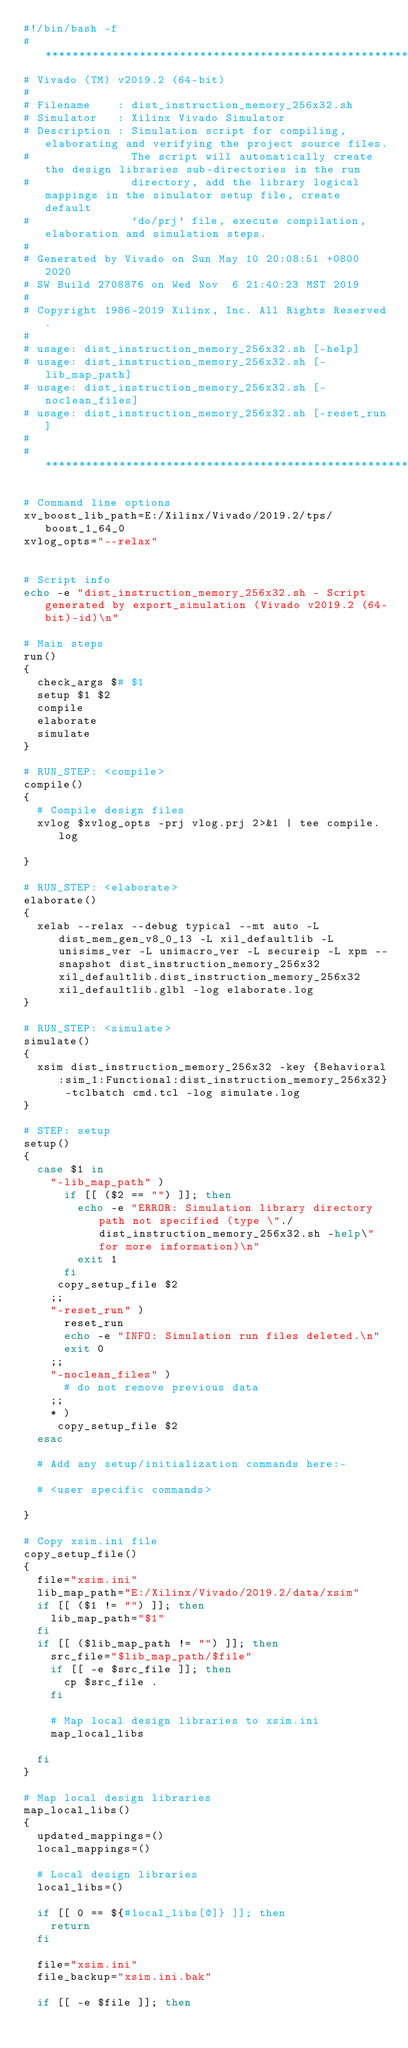<code> <loc_0><loc_0><loc_500><loc_500><_Bash_>#!/bin/bash -f
#*********************************************************************************************************
# Vivado (TM) v2019.2 (64-bit)
#
# Filename    : dist_instruction_memory_256x32.sh
# Simulator   : Xilinx Vivado Simulator
# Description : Simulation script for compiling, elaborating and verifying the project source files.
#               The script will automatically create the design libraries sub-directories in the run
#               directory, add the library logical mappings in the simulator setup file, create default
#               'do/prj' file, execute compilation, elaboration and simulation steps.
#
# Generated by Vivado on Sun May 10 20:08:51 +0800 2020
# SW Build 2708876 on Wed Nov  6 21:40:23 MST 2019
#
# Copyright 1986-2019 Xilinx, Inc. All Rights Reserved. 
#
# usage: dist_instruction_memory_256x32.sh [-help]
# usage: dist_instruction_memory_256x32.sh [-lib_map_path]
# usage: dist_instruction_memory_256x32.sh [-noclean_files]
# usage: dist_instruction_memory_256x32.sh [-reset_run]
#
#*********************************************************************************************************

# Command line options
xv_boost_lib_path=E:/Xilinx/Vivado/2019.2/tps/boost_1_64_0
xvlog_opts="--relax"


# Script info
echo -e "dist_instruction_memory_256x32.sh - Script generated by export_simulation (Vivado v2019.2 (64-bit)-id)\n"

# Main steps
run()
{
  check_args $# $1
  setup $1 $2
  compile
  elaborate
  simulate
}

# RUN_STEP: <compile>
compile()
{
  # Compile design files
  xvlog $xvlog_opts -prj vlog.prj 2>&1 | tee compile.log

}

# RUN_STEP: <elaborate>
elaborate()
{
  xelab --relax --debug typical --mt auto -L dist_mem_gen_v8_0_13 -L xil_defaultlib -L unisims_ver -L unimacro_ver -L secureip -L xpm --snapshot dist_instruction_memory_256x32 xil_defaultlib.dist_instruction_memory_256x32 xil_defaultlib.glbl -log elaborate.log
}

# RUN_STEP: <simulate>
simulate()
{
  xsim dist_instruction_memory_256x32 -key {Behavioral:sim_1:Functional:dist_instruction_memory_256x32} -tclbatch cmd.tcl -log simulate.log
}

# STEP: setup
setup()
{
  case $1 in
    "-lib_map_path" )
      if [[ ($2 == "") ]]; then
        echo -e "ERROR: Simulation library directory path not specified (type \"./dist_instruction_memory_256x32.sh -help\" for more information)\n"
        exit 1
      fi
     copy_setup_file $2
    ;;
    "-reset_run" )
      reset_run
      echo -e "INFO: Simulation run files deleted.\n"
      exit 0
    ;;
    "-noclean_files" )
      # do not remove previous data
    ;;
    * )
     copy_setup_file $2
  esac

  # Add any setup/initialization commands here:-

  # <user specific commands>

}

# Copy xsim.ini file
copy_setup_file()
{
  file="xsim.ini"
  lib_map_path="E:/Xilinx/Vivado/2019.2/data/xsim"
  if [[ ($1 != "") ]]; then
    lib_map_path="$1"
  fi
  if [[ ($lib_map_path != "") ]]; then
    src_file="$lib_map_path/$file"
    if [[ -e $src_file ]]; then
      cp $src_file .
    fi

    # Map local design libraries to xsim.ini
    map_local_libs

  fi
}

# Map local design libraries
map_local_libs()
{
  updated_mappings=()
  local_mappings=()

  # Local design libraries
  local_libs=()

  if [[ 0 == ${#local_libs[@]} ]]; then
    return
  fi

  file="xsim.ini"
  file_backup="xsim.ini.bak"

  if [[ -e $file ]]; then</code> 